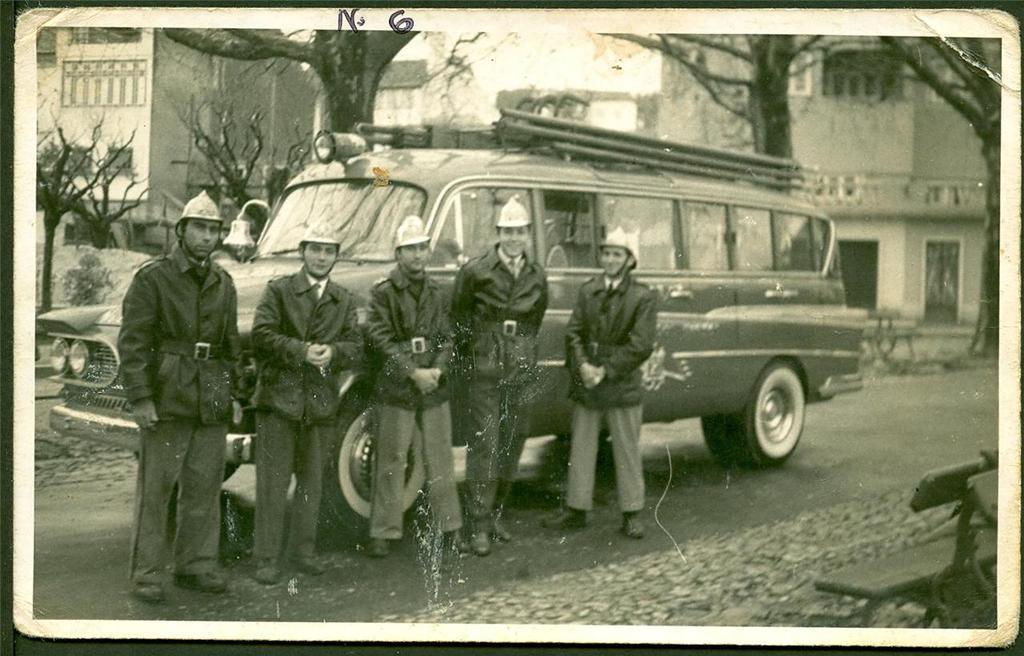What is the main subject of the photo in the image? The photo contains persons standing in front of a vehicle. What can be seen in the background of the photo? There is a building and dry trees in the background of the photo. How many boys are flying a kite in the image? There are no boys or kites present in the image. The photo shows persons standing in front of a vehicle, with a building and dry trees in the background. 